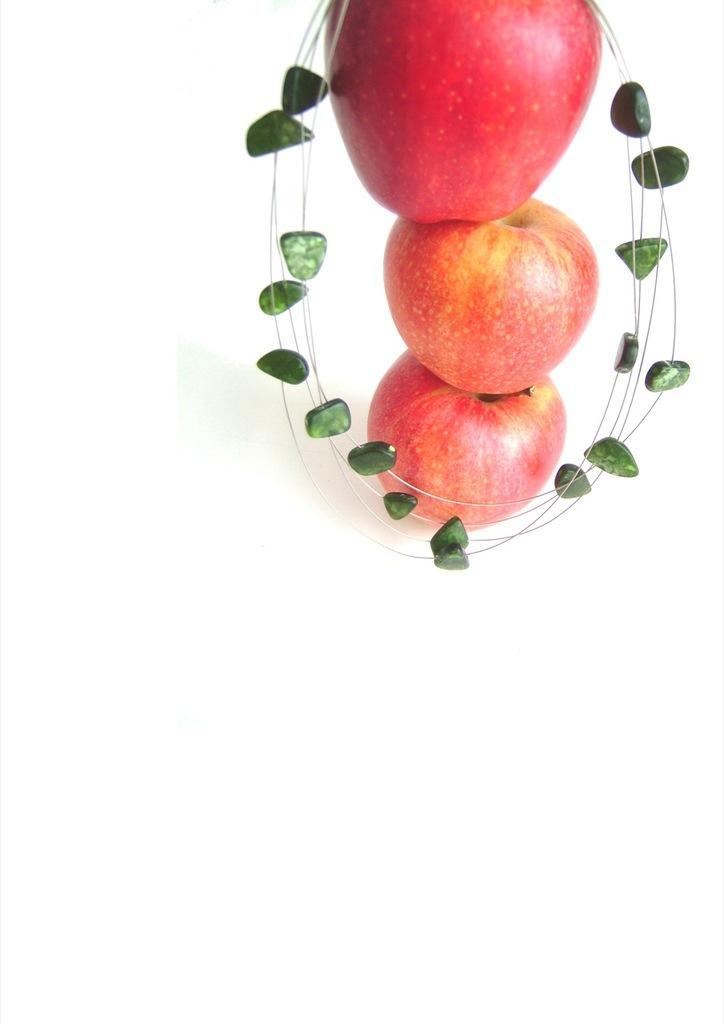What type of fruit is present in the image? There are apples in the image. What color are the objects surrounding the apples? The objects surrounding the apples are green. Can you see a kite made of oranges in the image? There is no kite made of oranges present in the image. 